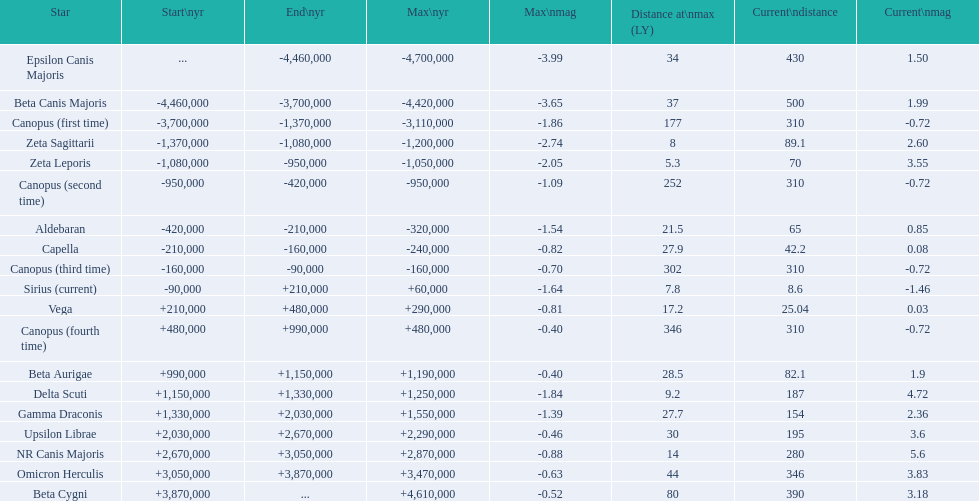Which star has the highest distance at maximum? Canopus (fourth time). 